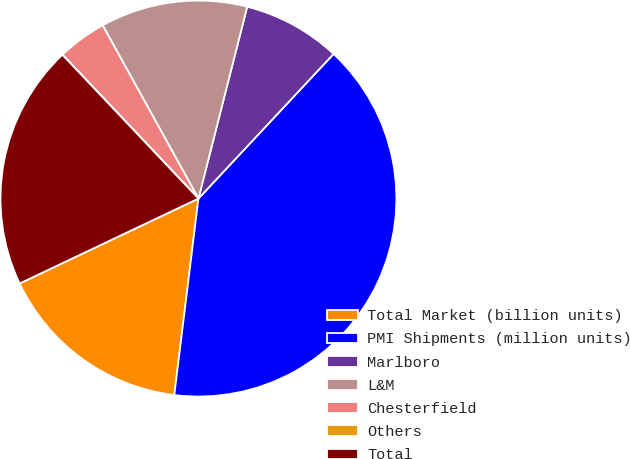Convert chart to OTSL. <chart><loc_0><loc_0><loc_500><loc_500><pie_chart><fcel>Total Market (billion units)<fcel>PMI Shipments (million units)<fcel>Marlboro<fcel>L&M<fcel>Chesterfield<fcel>Others<fcel>Total<nl><fcel>16.0%<fcel>39.99%<fcel>8.0%<fcel>12.0%<fcel>4.01%<fcel>0.01%<fcel>20.0%<nl></chart> 